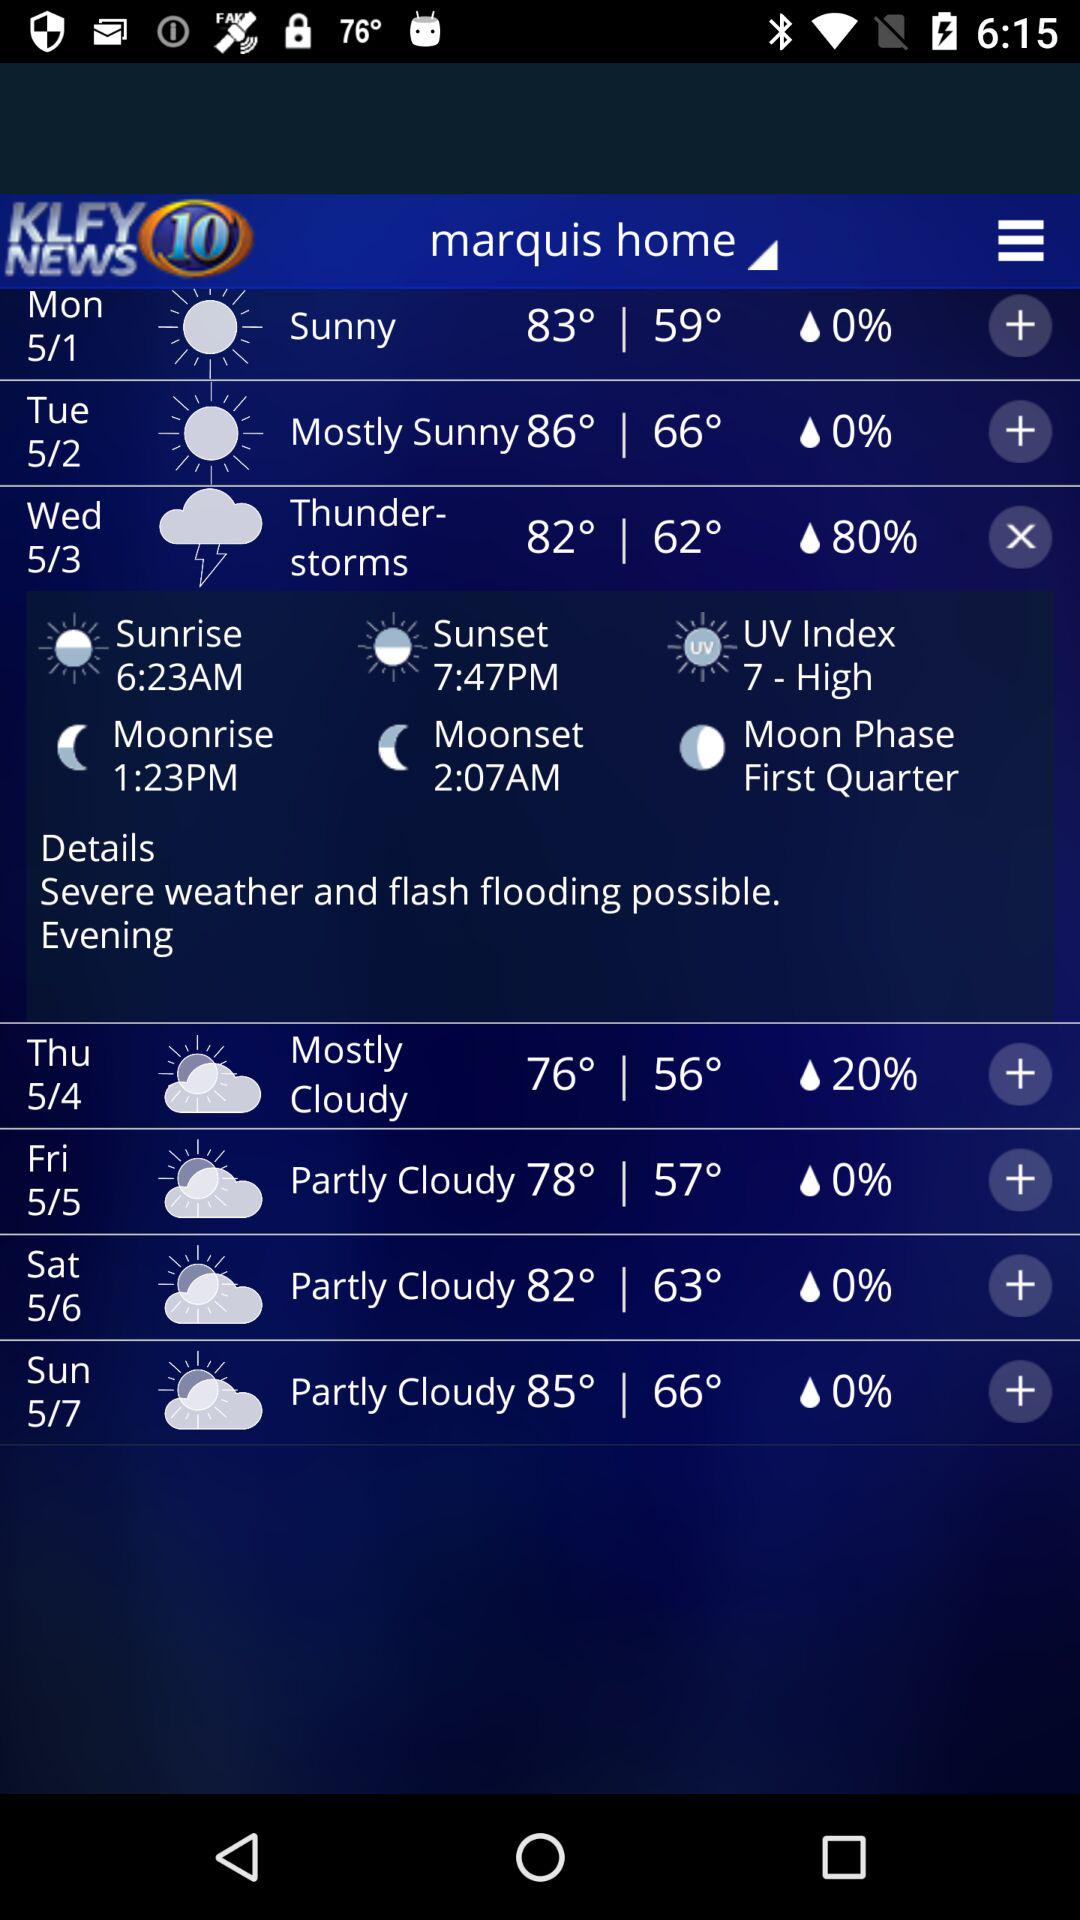How many degrees is the difference between the highest and lowest temperatures in the forecast?
Answer the question using a single word or phrase. 24 